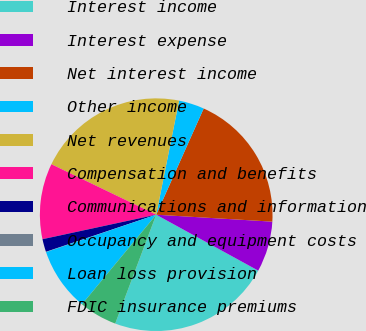Convert chart. <chart><loc_0><loc_0><loc_500><loc_500><pie_chart><fcel>Interest income<fcel>Interest expense<fcel>Net interest income<fcel>Other income<fcel>Net revenues<fcel>Compensation and benefits<fcel>Communications and information<fcel>Occupancy and equipment costs<fcel>Loan loss provision<fcel>FDIC insurance premiums<nl><fcel>22.75%<fcel>7.03%<fcel>19.26%<fcel>3.54%<fcel>21.01%<fcel>10.52%<fcel>1.79%<fcel>0.04%<fcel>8.78%<fcel>5.28%<nl></chart> 